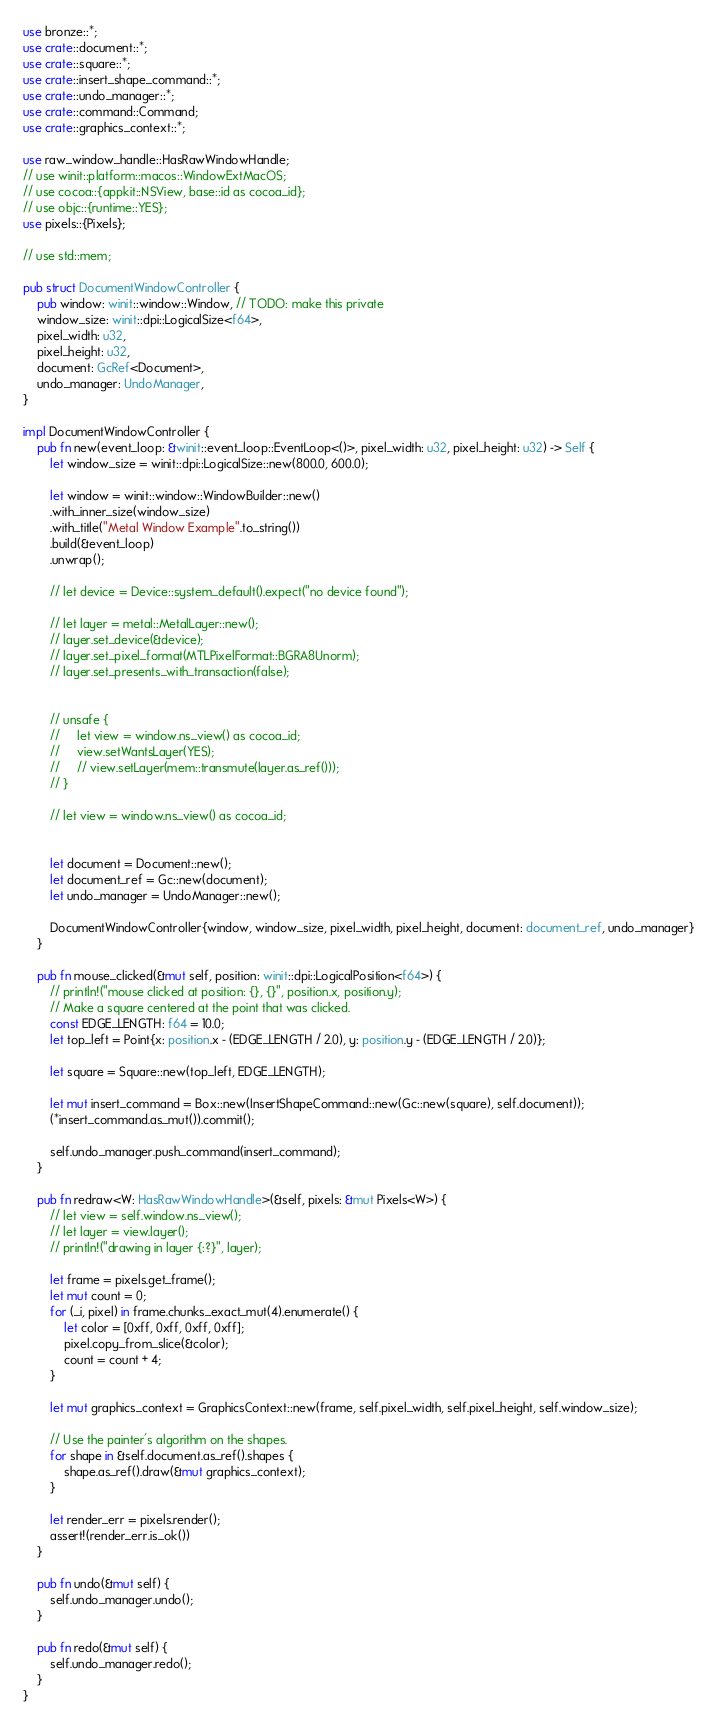<code> <loc_0><loc_0><loc_500><loc_500><_Rust_>use bronze::*;
use crate::document::*;
use crate::square::*;
use crate::insert_shape_command::*;
use crate::undo_manager::*;
use crate::command::Command;
use crate::graphics_context::*;

use raw_window_handle::HasRawWindowHandle;
// use winit::platform::macos::WindowExtMacOS;
// use cocoa::{appkit::NSView, base::id as cocoa_id};
// use objc::{runtime::YES};
use pixels::{Pixels};

// use std::mem;

pub struct DocumentWindowController {
    pub window: winit::window::Window, // TODO: make this private
    window_size: winit::dpi::LogicalSize<f64>,
    pixel_width: u32,
    pixel_height: u32,
    document: GcRef<Document>,
    undo_manager: UndoManager,
}

impl DocumentWindowController {
    pub fn new(event_loop: &winit::event_loop::EventLoop<()>, pixel_width: u32, pixel_height: u32) -> Self {
        let window_size = winit::dpi::LogicalSize::new(800.0, 600.0);
        
        let window = winit::window::WindowBuilder::new()
        .with_inner_size(window_size)
        .with_title("Metal Window Example".to_string())
        .build(&event_loop)
        .unwrap();

        // let device = Device::system_default().expect("no device found");

        // let layer = metal::MetalLayer::new();
        // layer.set_device(&device);
        // layer.set_pixel_format(MTLPixelFormat::BGRA8Unorm);
        // layer.set_presents_with_transaction(false);
    

        // unsafe {
        //     let view = window.ns_view() as cocoa_id;
        //     view.setWantsLayer(YES);
        //     // view.setLayer(mem::transmute(layer.as_ref()));
        // }

        // let view = window.ns_view() as cocoa_id;


        let document = Document::new();
        let document_ref = Gc::new(document);
        let undo_manager = UndoManager::new();

        DocumentWindowController{window, window_size, pixel_width, pixel_height, document: document_ref, undo_manager}
    }

    pub fn mouse_clicked(&mut self, position: winit::dpi::LogicalPosition<f64>) {
        // println!("mouse clicked at position: {}, {}", position.x, position.y);
        // Make a square centered at the point that was clicked.
        const EDGE_LENGTH: f64 = 10.0;
        let top_left = Point{x: position.x - (EDGE_LENGTH / 2.0), y: position.y - (EDGE_LENGTH / 2.0)};

        let square = Square::new(top_left, EDGE_LENGTH);
        
        let mut insert_command = Box::new(InsertShapeCommand::new(Gc::new(square), self.document));
        (*insert_command.as_mut()).commit();

        self.undo_manager.push_command(insert_command);
    }

    pub fn redraw<W: HasRawWindowHandle>(&self, pixels: &mut Pixels<W>) {
        // let view = self.window.ns_view();
        // let layer = view.layer();
        // println!("drawing in layer {:?}", layer);

        let frame = pixels.get_frame();
        let mut count = 0;
        for (_i, pixel) in frame.chunks_exact_mut(4).enumerate() {
            let color = [0xff, 0xff, 0xff, 0xff];
            pixel.copy_from_slice(&color);
            count = count + 4;
        }

        let mut graphics_context = GraphicsContext::new(frame, self.pixel_width, self.pixel_height, self.window_size);

        // Use the painter's algorithm on the shapes.
        for shape in &self.document.as_ref().shapes {
            shape.as_ref().draw(&mut graphics_context);
        }

        let render_err = pixels.render();
        assert!(render_err.is_ok())
    }

    pub fn undo(&mut self) {
        self.undo_manager.undo();
    }
    
    pub fn redo(&mut self) {
        self.undo_manager.redo();
    }
}</code> 